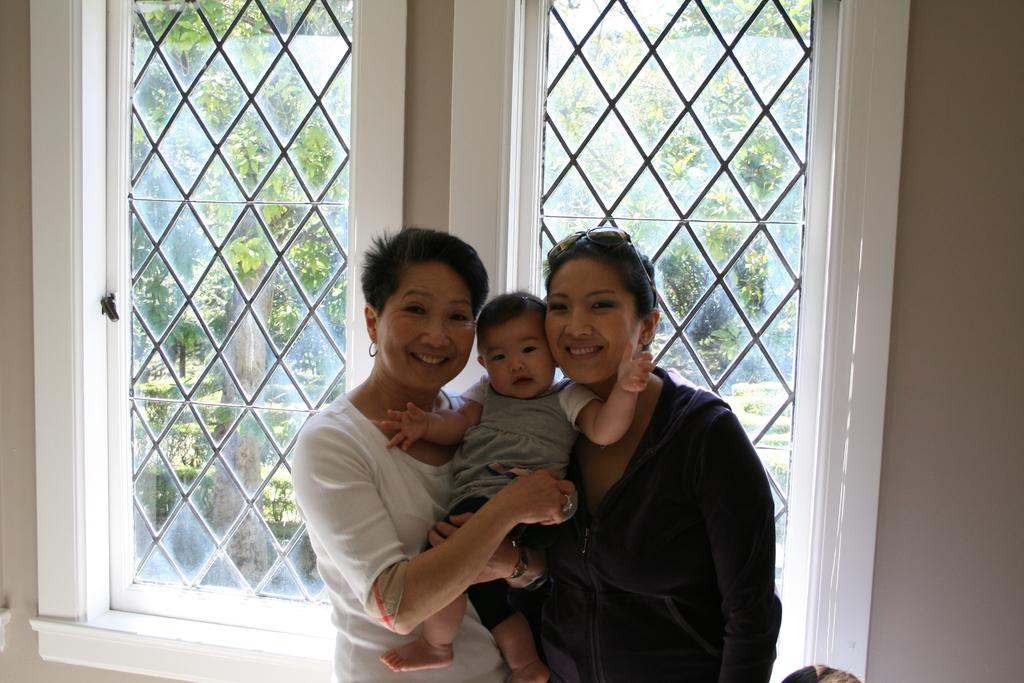How many people are present in the image? There are two persons standing in the image. What are the two persons doing? The two persons are holding a kid. What can be seen in the background of the image? There are windows with grilles in the background of the image, and trees are visible through the windows. What channel is the kid watching on the television in the image? There is no television present in the image, so it is not possible to determine what channel the kid might be watching. 